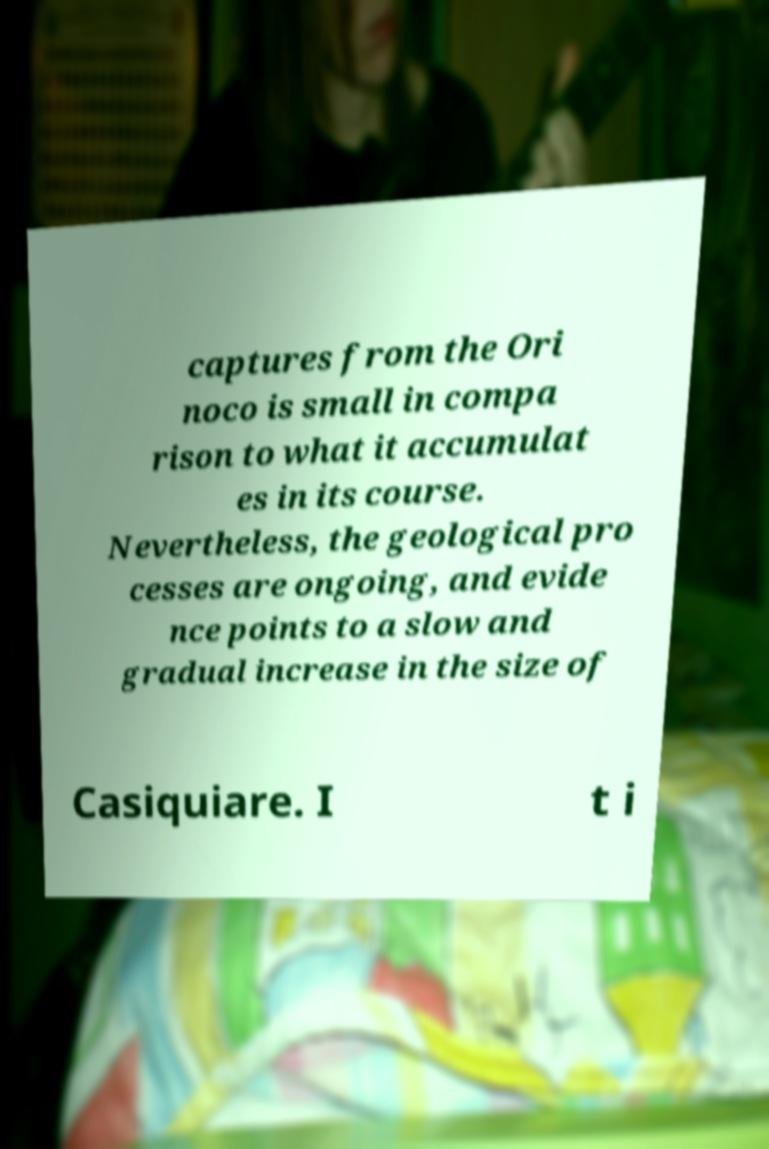I need the written content from this picture converted into text. Can you do that? captures from the Ori noco is small in compa rison to what it accumulat es in its course. Nevertheless, the geological pro cesses are ongoing, and evide nce points to a slow and gradual increase in the size of Casiquiare. I t i 